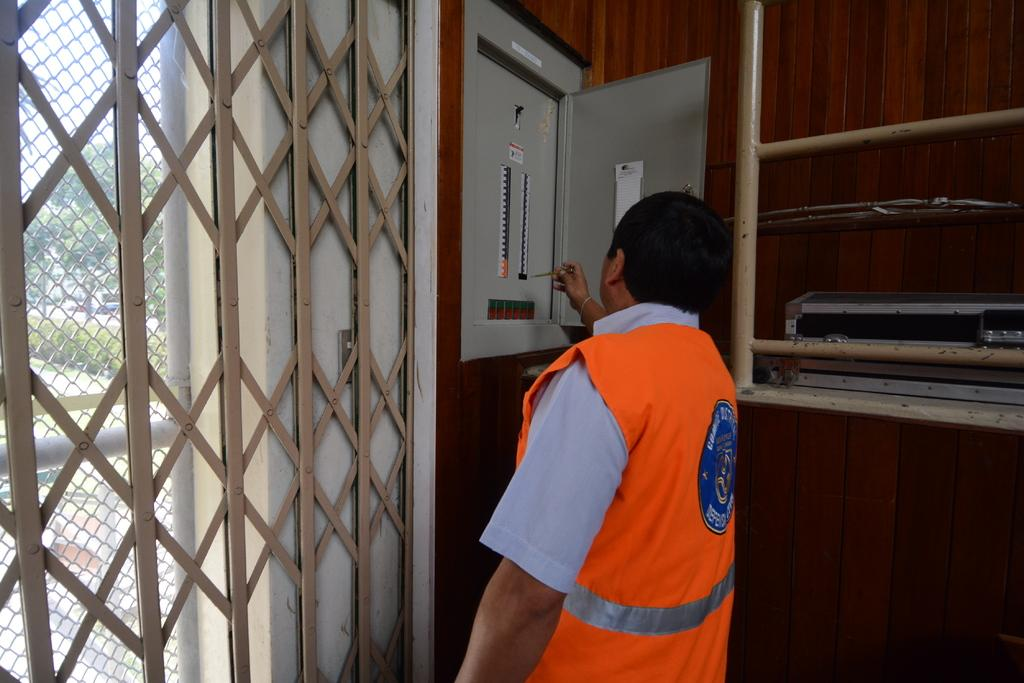What is the main subject of the image? There is a person in the image. What is the person holding in the image? The person is holding something. Can you describe the person's location in the image? The person is standing beside a grill. What else can be seen near the person in the image? There is an unspecified object to the side of the person. What type of birds can be seen flying near the wall in the image? There is no mention of birds or a wall in the image; it features a person standing beside a grill and holding something. 